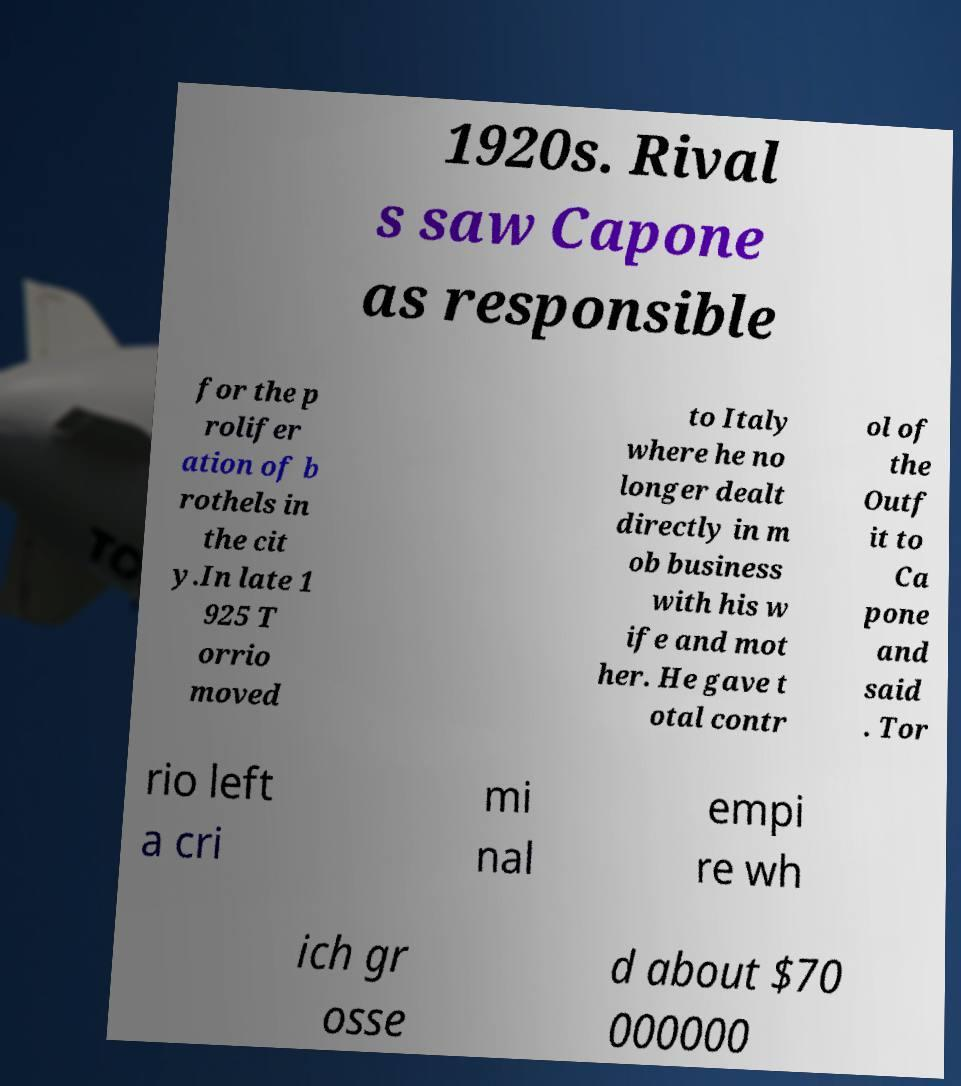There's text embedded in this image that I need extracted. Can you transcribe it verbatim? 1920s. Rival s saw Capone as responsible for the p rolifer ation of b rothels in the cit y.In late 1 925 T orrio moved to Italy where he no longer dealt directly in m ob business with his w ife and mot her. He gave t otal contr ol of the Outf it to Ca pone and said . Tor rio left a cri mi nal empi re wh ich gr osse d about $70 000000 